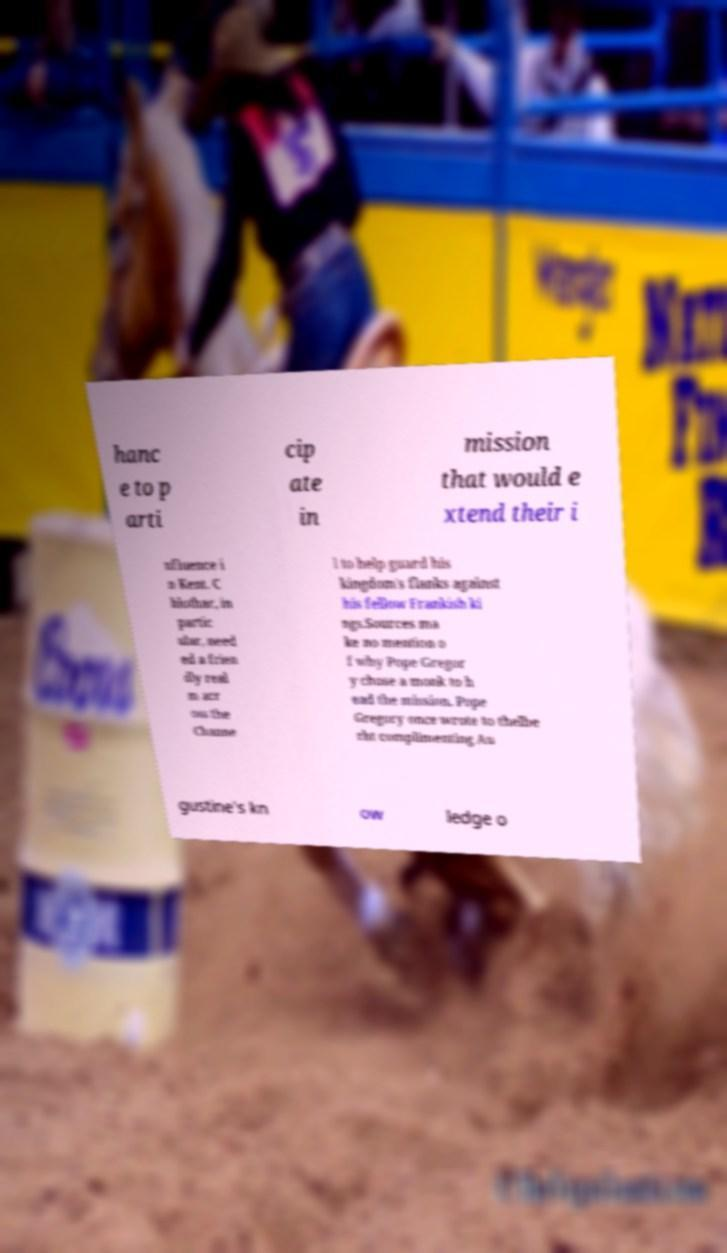What messages or text are displayed in this image? I need them in a readable, typed format. hanc e to p arti cip ate in mission that would e xtend their i nfluence i n Kent. C hlothar, in partic ular, need ed a frien dly real m acr oss the Channe l to help guard his kingdom's flanks against his fellow Frankish ki ngs.Sources ma ke no mention o f why Pope Gregor y chose a monk to h ead the mission. Pope Gregory once wrote to thelbe rht complimenting Au gustine's kn ow ledge o 